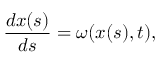<formula> <loc_0><loc_0><loc_500><loc_500>\frac { d \boldsymbol x ( s ) } { d s } = \omega ( \boldsymbol x ( s ) , t ) ,</formula> 